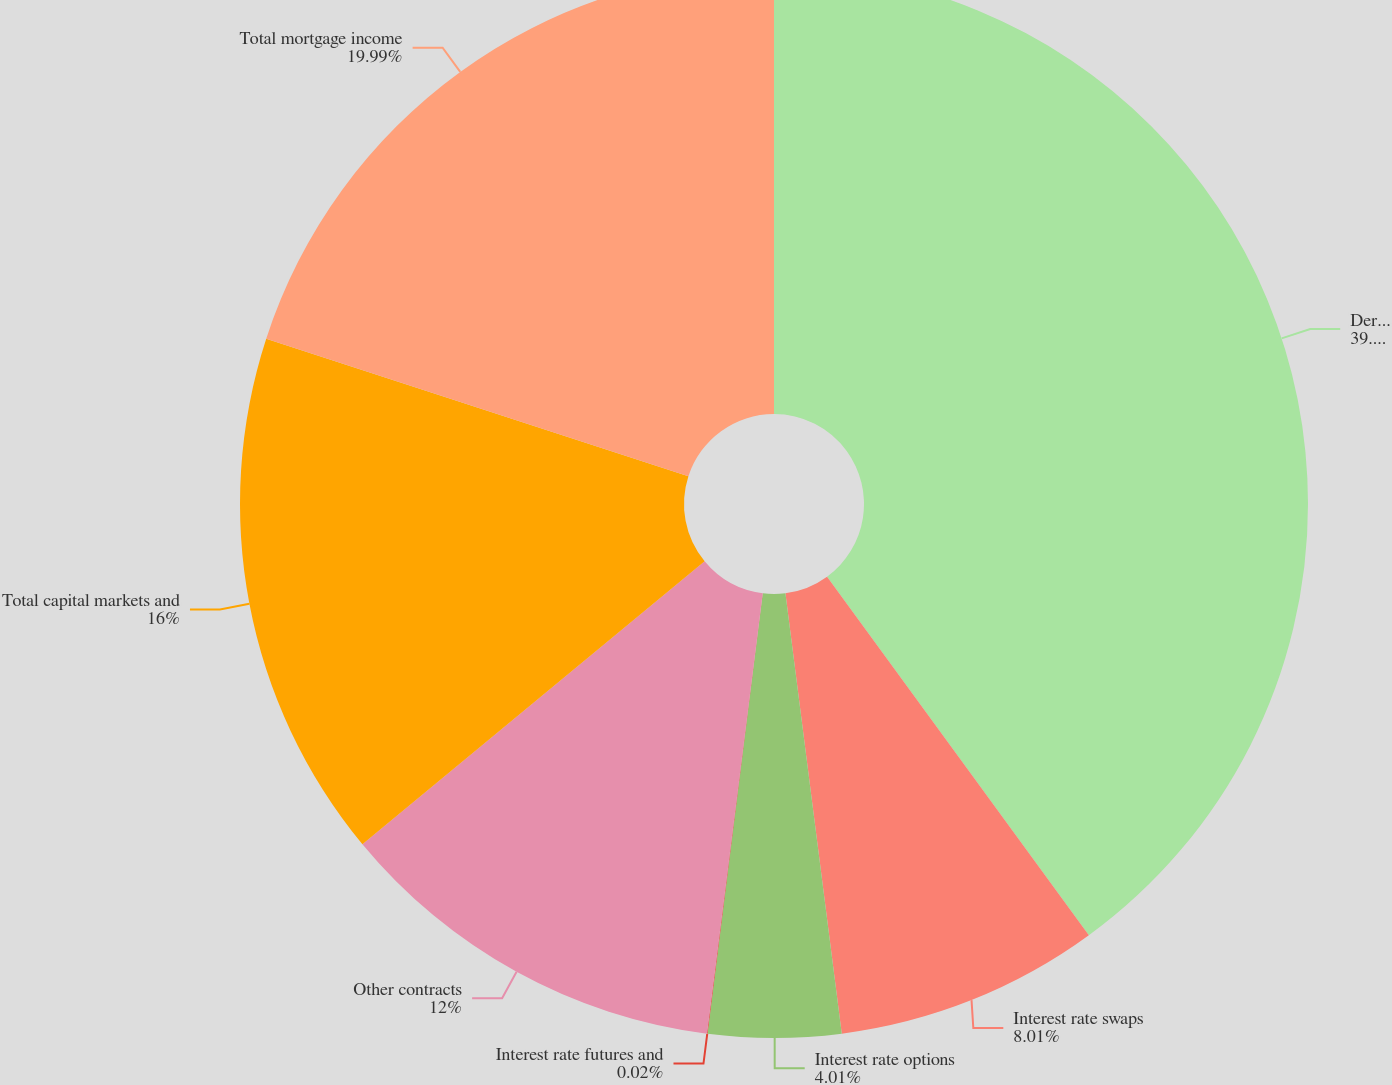Convert chart. <chart><loc_0><loc_0><loc_500><loc_500><pie_chart><fcel>Derivatives Not Designated as<fcel>Interest rate swaps<fcel>Interest rate options<fcel>Interest rate futures and<fcel>Other contracts<fcel>Total capital markets and<fcel>Total mortgage income<nl><fcel>39.96%<fcel>8.01%<fcel>4.01%<fcel>0.02%<fcel>12.0%<fcel>16.0%<fcel>19.99%<nl></chart> 